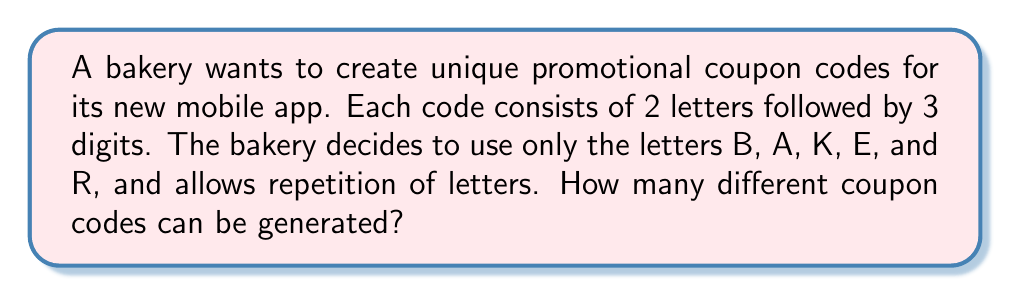Provide a solution to this math problem. Let's break this down step-by-step:

1) For the letters:
   - We have 5 choices (B, A, K, E, R) for each of the 2 letter positions.
   - We allow repetition, so we can use the same letter twice if needed.
   - This is a case of repetition allowed, so we use the multiplication principle.
   - Number of possibilities for letters = $5 \times 5 = 5^2 = 25$

2) For the digits:
   - We have 10 choices (0-9) for each of the 3 digit positions.
   - Again, repetition is allowed.
   - Number of possibilities for digits = $10 \times 10 \times 10 = 10^3 = 1000$

3) To get the total number of possible codes:
   - We multiply the number of possibilities for letters and digits.
   - Total number of codes = $25 \times 1000 = 25,000$

Therefore, the bakery can generate 25,000 unique coupon codes for its mobile app.
Answer: $25,000$ 